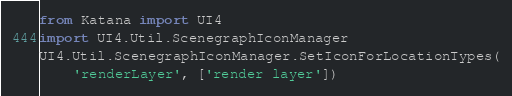Convert code to text. <code><loc_0><loc_0><loc_500><loc_500><_Python_>from Katana import UI4
import UI4.Util.ScenegraphIconManager
UI4.Util.ScenegraphIconManager.SetIconForLocationTypes(
    'renderLayer', ['render layer'])
</code> 